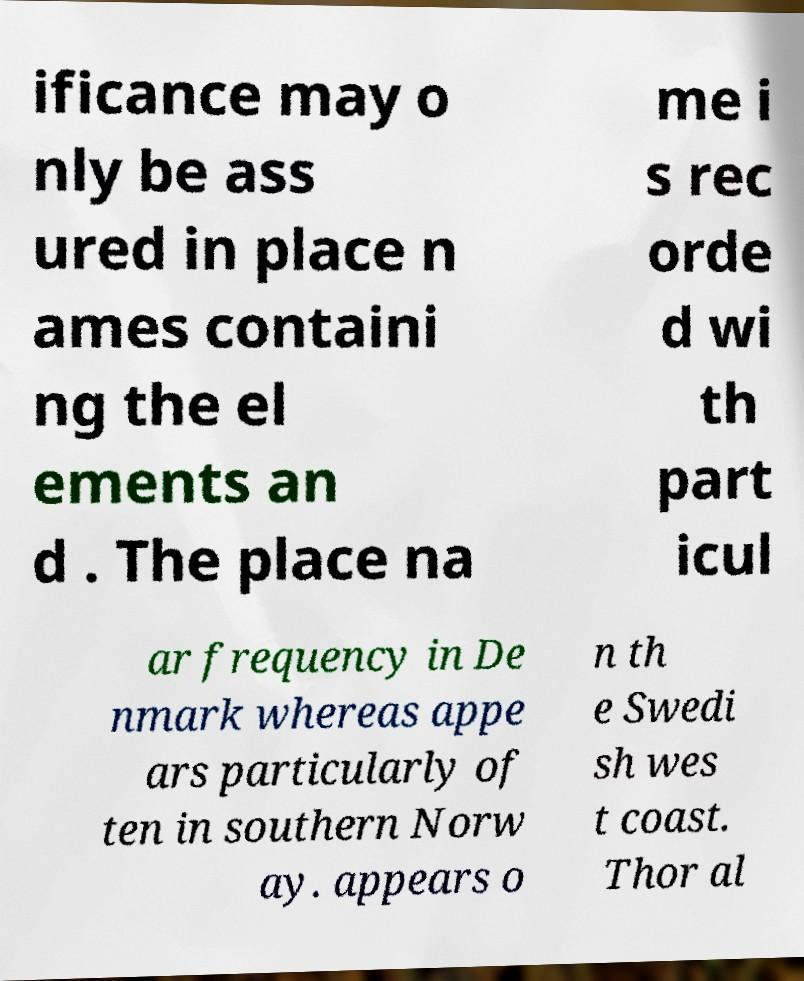I need the written content from this picture converted into text. Can you do that? ificance may o nly be ass ured in place n ames containi ng the el ements an d . The place na me i s rec orde d wi th part icul ar frequency in De nmark whereas appe ars particularly of ten in southern Norw ay. appears o n th e Swedi sh wes t coast. Thor al 